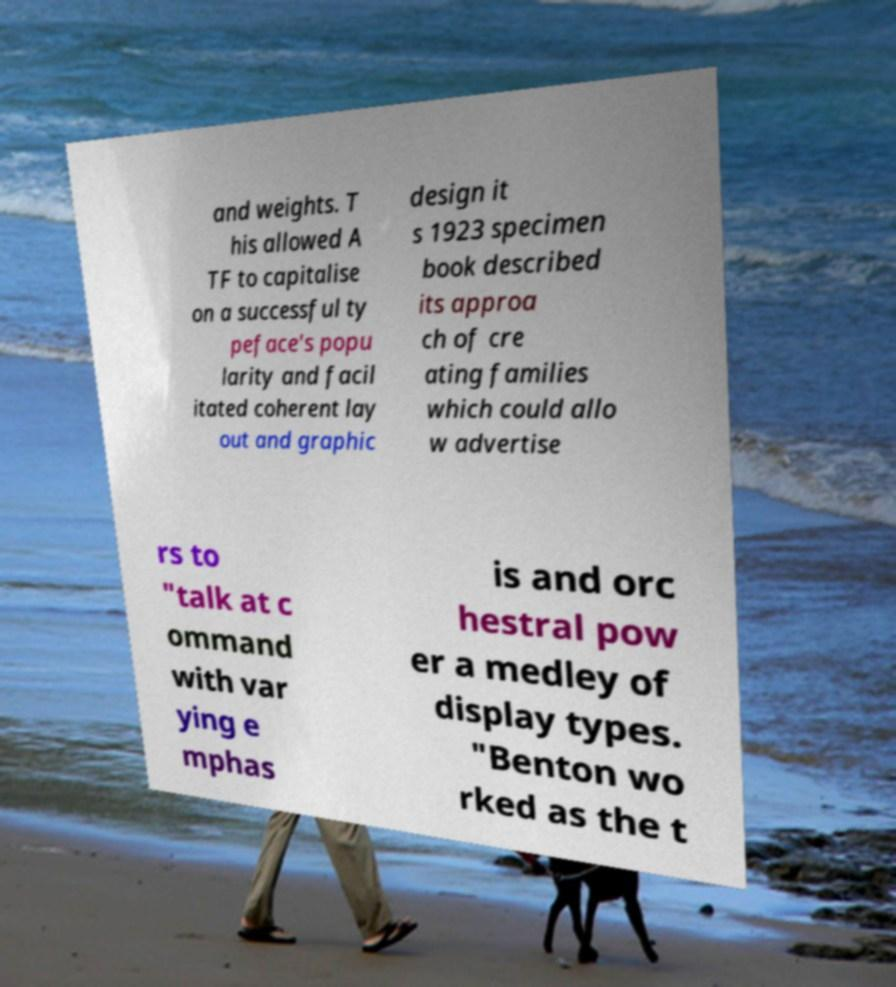I need the written content from this picture converted into text. Can you do that? and weights. T his allowed A TF to capitalise on a successful ty peface's popu larity and facil itated coherent lay out and graphic design it s 1923 specimen book described its approa ch of cre ating families which could allo w advertise rs to "talk at c ommand with var ying e mphas is and orc hestral pow er a medley of display types. "Benton wo rked as the t 